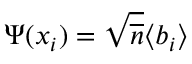Convert formula to latex. <formula><loc_0><loc_0><loc_500><loc_500>\Psi ( x _ { i } ) = \sqrt { \overline { n } } \langle b _ { i } \rangle</formula> 